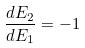<formula> <loc_0><loc_0><loc_500><loc_500>\frac { d E _ { 2 } } { d E _ { 1 } } = - 1</formula> 